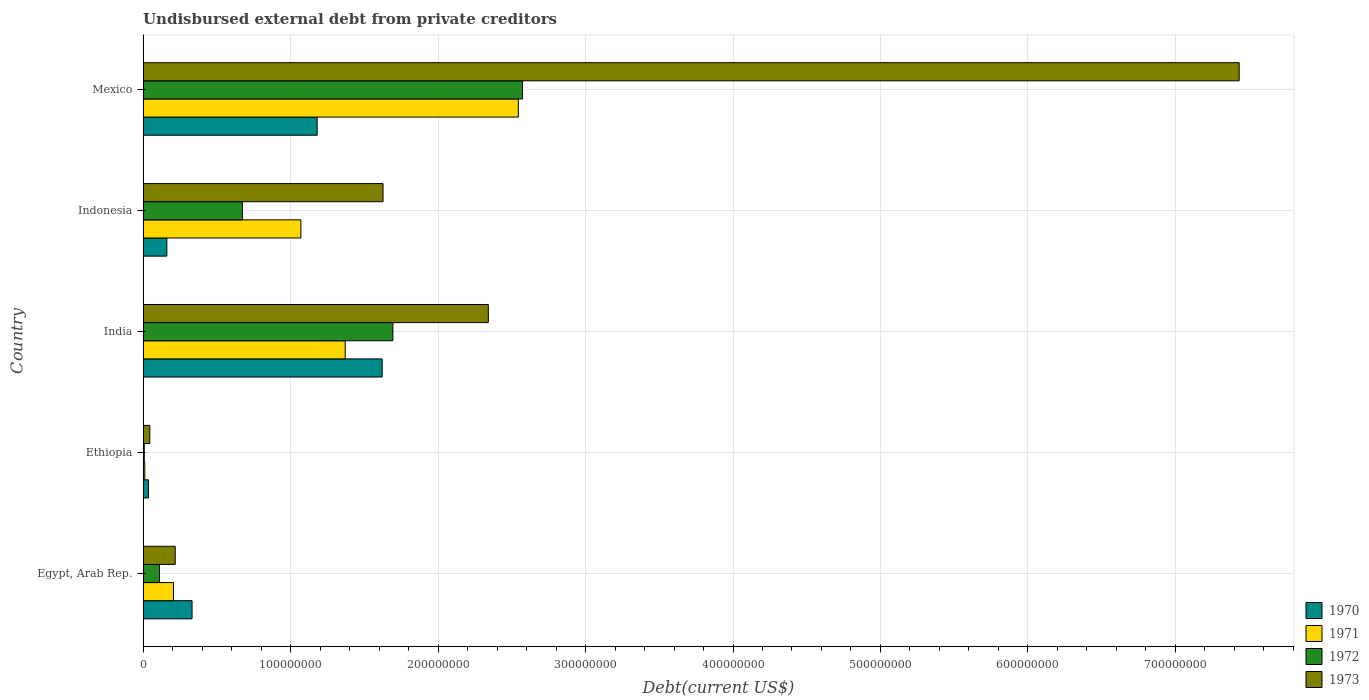How many different coloured bars are there?
Your answer should be compact. 4. How many groups of bars are there?
Your answer should be compact. 5. Are the number of bars on each tick of the Y-axis equal?
Keep it short and to the point. Yes. What is the label of the 4th group of bars from the top?
Provide a succinct answer. Ethiopia. In how many cases, is the number of bars for a given country not equal to the number of legend labels?
Offer a terse response. 0. What is the total debt in 1971 in Indonesia?
Ensure brevity in your answer.  1.07e+08. Across all countries, what is the maximum total debt in 1972?
Provide a short and direct response. 2.57e+08. Across all countries, what is the minimum total debt in 1973?
Your answer should be very brief. 4.57e+06. In which country was the total debt in 1971 maximum?
Your answer should be very brief. Mexico. In which country was the total debt in 1970 minimum?
Provide a short and direct response. Ethiopia. What is the total total debt in 1973 in the graph?
Provide a short and direct response. 1.17e+09. What is the difference between the total debt in 1973 in India and that in Mexico?
Your response must be concise. -5.09e+08. What is the difference between the total debt in 1972 in Mexico and the total debt in 1970 in Ethiopia?
Offer a very short reply. 2.54e+08. What is the average total debt in 1972 per country?
Provide a short and direct response. 1.01e+08. What is the difference between the total debt in 1970 and total debt in 1973 in India?
Keep it short and to the point. -7.20e+07. In how many countries, is the total debt in 1971 greater than 100000000 US$?
Ensure brevity in your answer.  3. What is the ratio of the total debt in 1971 in Ethiopia to that in Indonesia?
Provide a succinct answer. 0.01. What is the difference between the highest and the second highest total debt in 1972?
Your answer should be very brief. 8.79e+07. What is the difference between the highest and the lowest total debt in 1970?
Ensure brevity in your answer.  1.58e+08. In how many countries, is the total debt in 1972 greater than the average total debt in 1972 taken over all countries?
Your response must be concise. 2. Is the sum of the total debt in 1972 in Indonesia and Mexico greater than the maximum total debt in 1973 across all countries?
Provide a succinct answer. No. How many bars are there?
Your answer should be compact. 20. Are all the bars in the graph horizontal?
Your response must be concise. Yes. Are the values on the major ticks of X-axis written in scientific E-notation?
Your response must be concise. No. Where does the legend appear in the graph?
Ensure brevity in your answer.  Bottom right. How many legend labels are there?
Offer a terse response. 4. How are the legend labels stacked?
Your answer should be very brief. Vertical. What is the title of the graph?
Offer a very short reply. Undisbursed external debt from private creditors. Does "1990" appear as one of the legend labels in the graph?
Ensure brevity in your answer.  No. What is the label or title of the X-axis?
Make the answer very short. Debt(current US$). What is the label or title of the Y-axis?
Provide a short and direct response. Country. What is the Debt(current US$) in 1970 in Egypt, Arab Rep.?
Your answer should be very brief. 3.32e+07. What is the Debt(current US$) of 1971 in Egypt, Arab Rep.?
Give a very brief answer. 2.06e+07. What is the Debt(current US$) of 1972 in Egypt, Arab Rep.?
Your response must be concise. 1.11e+07. What is the Debt(current US$) of 1973 in Egypt, Arab Rep.?
Offer a terse response. 2.18e+07. What is the Debt(current US$) of 1970 in Ethiopia?
Your response must be concise. 3.70e+06. What is the Debt(current US$) of 1971 in Ethiopia?
Offer a very short reply. 1.16e+06. What is the Debt(current US$) in 1972 in Ethiopia?
Ensure brevity in your answer.  8.20e+05. What is the Debt(current US$) of 1973 in Ethiopia?
Provide a succinct answer. 4.57e+06. What is the Debt(current US$) in 1970 in India?
Keep it short and to the point. 1.62e+08. What is the Debt(current US$) of 1971 in India?
Provide a short and direct response. 1.37e+08. What is the Debt(current US$) in 1972 in India?
Offer a very short reply. 1.69e+08. What is the Debt(current US$) of 1973 in India?
Your response must be concise. 2.34e+08. What is the Debt(current US$) in 1970 in Indonesia?
Provide a short and direct response. 1.61e+07. What is the Debt(current US$) of 1971 in Indonesia?
Provide a succinct answer. 1.07e+08. What is the Debt(current US$) of 1972 in Indonesia?
Make the answer very short. 6.74e+07. What is the Debt(current US$) of 1973 in Indonesia?
Offer a very short reply. 1.63e+08. What is the Debt(current US$) of 1970 in Mexico?
Make the answer very short. 1.18e+08. What is the Debt(current US$) in 1971 in Mexico?
Offer a very short reply. 2.54e+08. What is the Debt(current US$) in 1972 in Mexico?
Give a very brief answer. 2.57e+08. What is the Debt(current US$) of 1973 in Mexico?
Provide a short and direct response. 7.43e+08. Across all countries, what is the maximum Debt(current US$) in 1970?
Your answer should be very brief. 1.62e+08. Across all countries, what is the maximum Debt(current US$) of 1971?
Your answer should be compact. 2.54e+08. Across all countries, what is the maximum Debt(current US$) of 1972?
Provide a succinct answer. 2.57e+08. Across all countries, what is the maximum Debt(current US$) in 1973?
Keep it short and to the point. 7.43e+08. Across all countries, what is the minimum Debt(current US$) in 1970?
Your answer should be compact. 3.70e+06. Across all countries, what is the minimum Debt(current US$) of 1971?
Make the answer very short. 1.16e+06. Across all countries, what is the minimum Debt(current US$) in 1972?
Give a very brief answer. 8.20e+05. Across all countries, what is the minimum Debt(current US$) in 1973?
Keep it short and to the point. 4.57e+06. What is the total Debt(current US$) in 1970 in the graph?
Your answer should be compact. 3.33e+08. What is the total Debt(current US$) in 1971 in the graph?
Give a very brief answer. 5.20e+08. What is the total Debt(current US$) of 1972 in the graph?
Your answer should be compact. 5.06e+08. What is the total Debt(current US$) of 1973 in the graph?
Give a very brief answer. 1.17e+09. What is the difference between the Debt(current US$) in 1970 in Egypt, Arab Rep. and that in Ethiopia?
Ensure brevity in your answer.  2.95e+07. What is the difference between the Debt(current US$) in 1971 in Egypt, Arab Rep. and that in Ethiopia?
Provide a succinct answer. 1.95e+07. What is the difference between the Debt(current US$) in 1972 in Egypt, Arab Rep. and that in Ethiopia?
Your answer should be compact. 1.03e+07. What is the difference between the Debt(current US$) in 1973 in Egypt, Arab Rep. and that in Ethiopia?
Offer a terse response. 1.72e+07. What is the difference between the Debt(current US$) in 1970 in Egypt, Arab Rep. and that in India?
Offer a terse response. -1.29e+08. What is the difference between the Debt(current US$) in 1971 in Egypt, Arab Rep. and that in India?
Provide a short and direct response. -1.16e+08. What is the difference between the Debt(current US$) of 1972 in Egypt, Arab Rep. and that in India?
Offer a terse response. -1.58e+08. What is the difference between the Debt(current US$) of 1973 in Egypt, Arab Rep. and that in India?
Offer a very short reply. -2.12e+08. What is the difference between the Debt(current US$) of 1970 in Egypt, Arab Rep. and that in Indonesia?
Your response must be concise. 1.71e+07. What is the difference between the Debt(current US$) of 1971 in Egypt, Arab Rep. and that in Indonesia?
Give a very brief answer. -8.64e+07. What is the difference between the Debt(current US$) in 1972 in Egypt, Arab Rep. and that in Indonesia?
Give a very brief answer. -5.62e+07. What is the difference between the Debt(current US$) of 1973 in Egypt, Arab Rep. and that in Indonesia?
Provide a succinct answer. -1.41e+08. What is the difference between the Debt(current US$) of 1970 in Egypt, Arab Rep. and that in Mexico?
Provide a short and direct response. -8.48e+07. What is the difference between the Debt(current US$) in 1971 in Egypt, Arab Rep. and that in Mexico?
Give a very brief answer. -2.34e+08. What is the difference between the Debt(current US$) of 1972 in Egypt, Arab Rep. and that in Mexico?
Your response must be concise. -2.46e+08. What is the difference between the Debt(current US$) in 1973 in Egypt, Arab Rep. and that in Mexico?
Make the answer very short. -7.21e+08. What is the difference between the Debt(current US$) of 1970 in Ethiopia and that in India?
Offer a terse response. -1.58e+08. What is the difference between the Debt(current US$) of 1971 in Ethiopia and that in India?
Your response must be concise. -1.36e+08. What is the difference between the Debt(current US$) in 1972 in Ethiopia and that in India?
Your answer should be compact. -1.69e+08. What is the difference between the Debt(current US$) in 1973 in Ethiopia and that in India?
Offer a very short reply. -2.30e+08. What is the difference between the Debt(current US$) of 1970 in Ethiopia and that in Indonesia?
Keep it short and to the point. -1.24e+07. What is the difference between the Debt(current US$) of 1971 in Ethiopia and that in Indonesia?
Provide a succinct answer. -1.06e+08. What is the difference between the Debt(current US$) in 1972 in Ethiopia and that in Indonesia?
Provide a succinct answer. -6.66e+07. What is the difference between the Debt(current US$) in 1973 in Ethiopia and that in Indonesia?
Ensure brevity in your answer.  -1.58e+08. What is the difference between the Debt(current US$) in 1970 in Ethiopia and that in Mexico?
Your response must be concise. -1.14e+08. What is the difference between the Debt(current US$) in 1971 in Ethiopia and that in Mexico?
Provide a short and direct response. -2.53e+08. What is the difference between the Debt(current US$) of 1972 in Ethiopia and that in Mexico?
Make the answer very short. -2.56e+08. What is the difference between the Debt(current US$) in 1973 in Ethiopia and that in Mexico?
Your response must be concise. -7.39e+08. What is the difference between the Debt(current US$) in 1970 in India and that in Indonesia?
Offer a very short reply. 1.46e+08. What is the difference between the Debt(current US$) of 1971 in India and that in Indonesia?
Your answer should be very brief. 3.00e+07. What is the difference between the Debt(current US$) in 1972 in India and that in Indonesia?
Give a very brief answer. 1.02e+08. What is the difference between the Debt(current US$) of 1973 in India and that in Indonesia?
Offer a terse response. 7.14e+07. What is the difference between the Debt(current US$) of 1970 in India and that in Mexico?
Offer a very short reply. 4.41e+07. What is the difference between the Debt(current US$) of 1971 in India and that in Mexico?
Provide a succinct answer. -1.17e+08. What is the difference between the Debt(current US$) in 1972 in India and that in Mexico?
Your response must be concise. -8.79e+07. What is the difference between the Debt(current US$) of 1973 in India and that in Mexico?
Keep it short and to the point. -5.09e+08. What is the difference between the Debt(current US$) in 1970 in Indonesia and that in Mexico?
Provide a succinct answer. -1.02e+08. What is the difference between the Debt(current US$) of 1971 in Indonesia and that in Mexico?
Give a very brief answer. -1.47e+08. What is the difference between the Debt(current US$) in 1972 in Indonesia and that in Mexico?
Your response must be concise. -1.90e+08. What is the difference between the Debt(current US$) in 1973 in Indonesia and that in Mexico?
Your response must be concise. -5.81e+08. What is the difference between the Debt(current US$) of 1970 in Egypt, Arab Rep. and the Debt(current US$) of 1971 in Ethiopia?
Offer a very short reply. 3.21e+07. What is the difference between the Debt(current US$) in 1970 in Egypt, Arab Rep. and the Debt(current US$) in 1972 in Ethiopia?
Give a very brief answer. 3.24e+07. What is the difference between the Debt(current US$) of 1970 in Egypt, Arab Rep. and the Debt(current US$) of 1973 in Ethiopia?
Provide a short and direct response. 2.87e+07. What is the difference between the Debt(current US$) in 1971 in Egypt, Arab Rep. and the Debt(current US$) in 1972 in Ethiopia?
Ensure brevity in your answer.  1.98e+07. What is the difference between the Debt(current US$) in 1971 in Egypt, Arab Rep. and the Debt(current US$) in 1973 in Ethiopia?
Keep it short and to the point. 1.61e+07. What is the difference between the Debt(current US$) in 1972 in Egypt, Arab Rep. and the Debt(current US$) in 1973 in Ethiopia?
Make the answer very short. 6.56e+06. What is the difference between the Debt(current US$) of 1970 in Egypt, Arab Rep. and the Debt(current US$) of 1971 in India?
Provide a short and direct response. -1.04e+08. What is the difference between the Debt(current US$) in 1970 in Egypt, Arab Rep. and the Debt(current US$) in 1972 in India?
Offer a very short reply. -1.36e+08. What is the difference between the Debt(current US$) in 1970 in Egypt, Arab Rep. and the Debt(current US$) in 1973 in India?
Make the answer very short. -2.01e+08. What is the difference between the Debt(current US$) of 1971 in Egypt, Arab Rep. and the Debt(current US$) of 1972 in India?
Ensure brevity in your answer.  -1.49e+08. What is the difference between the Debt(current US$) in 1971 in Egypt, Arab Rep. and the Debt(current US$) in 1973 in India?
Your answer should be compact. -2.13e+08. What is the difference between the Debt(current US$) of 1972 in Egypt, Arab Rep. and the Debt(current US$) of 1973 in India?
Your answer should be compact. -2.23e+08. What is the difference between the Debt(current US$) in 1970 in Egypt, Arab Rep. and the Debt(current US$) in 1971 in Indonesia?
Offer a terse response. -7.38e+07. What is the difference between the Debt(current US$) in 1970 in Egypt, Arab Rep. and the Debt(current US$) in 1972 in Indonesia?
Provide a succinct answer. -3.42e+07. What is the difference between the Debt(current US$) of 1970 in Egypt, Arab Rep. and the Debt(current US$) of 1973 in Indonesia?
Make the answer very short. -1.29e+08. What is the difference between the Debt(current US$) in 1971 in Egypt, Arab Rep. and the Debt(current US$) in 1972 in Indonesia?
Give a very brief answer. -4.67e+07. What is the difference between the Debt(current US$) of 1971 in Egypt, Arab Rep. and the Debt(current US$) of 1973 in Indonesia?
Provide a short and direct response. -1.42e+08. What is the difference between the Debt(current US$) in 1972 in Egypt, Arab Rep. and the Debt(current US$) in 1973 in Indonesia?
Keep it short and to the point. -1.52e+08. What is the difference between the Debt(current US$) of 1970 in Egypt, Arab Rep. and the Debt(current US$) of 1971 in Mexico?
Provide a short and direct response. -2.21e+08. What is the difference between the Debt(current US$) in 1970 in Egypt, Arab Rep. and the Debt(current US$) in 1972 in Mexico?
Keep it short and to the point. -2.24e+08. What is the difference between the Debt(current US$) in 1970 in Egypt, Arab Rep. and the Debt(current US$) in 1973 in Mexico?
Your answer should be very brief. -7.10e+08. What is the difference between the Debt(current US$) in 1971 in Egypt, Arab Rep. and the Debt(current US$) in 1972 in Mexico?
Your response must be concise. -2.37e+08. What is the difference between the Debt(current US$) in 1971 in Egypt, Arab Rep. and the Debt(current US$) in 1973 in Mexico?
Your answer should be compact. -7.23e+08. What is the difference between the Debt(current US$) of 1972 in Egypt, Arab Rep. and the Debt(current US$) of 1973 in Mexico?
Ensure brevity in your answer.  -7.32e+08. What is the difference between the Debt(current US$) in 1970 in Ethiopia and the Debt(current US$) in 1971 in India?
Your response must be concise. -1.33e+08. What is the difference between the Debt(current US$) in 1970 in Ethiopia and the Debt(current US$) in 1972 in India?
Provide a short and direct response. -1.66e+08. What is the difference between the Debt(current US$) of 1970 in Ethiopia and the Debt(current US$) of 1973 in India?
Provide a short and direct response. -2.30e+08. What is the difference between the Debt(current US$) in 1971 in Ethiopia and the Debt(current US$) in 1972 in India?
Ensure brevity in your answer.  -1.68e+08. What is the difference between the Debt(current US$) of 1971 in Ethiopia and the Debt(current US$) of 1973 in India?
Provide a short and direct response. -2.33e+08. What is the difference between the Debt(current US$) of 1972 in Ethiopia and the Debt(current US$) of 1973 in India?
Your answer should be very brief. -2.33e+08. What is the difference between the Debt(current US$) of 1970 in Ethiopia and the Debt(current US$) of 1971 in Indonesia?
Your answer should be compact. -1.03e+08. What is the difference between the Debt(current US$) in 1970 in Ethiopia and the Debt(current US$) in 1972 in Indonesia?
Provide a short and direct response. -6.37e+07. What is the difference between the Debt(current US$) of 1970 in Ethiopia and the Debt(current US$) of 1973 in Indonesia?
Your response must be concise. -1.59e+08. What is the difference between the Debt(current US$) in 1971 in Ethiopia and the Debt(current US$) in 1972 in Indonesia?
Make the answer very short. -6.62e+07. What is the difference between the Debt(current US$) in 1971 in Ethiopia and the Debt(current US$) in 1973 in Indonesia?
Make the answer very short. -1.62e+08. What is the difference between the Debt(current US$) in 1972 in Ethiopia and the Debt(current US$) in 1973 in Indonesia?
Your response must be concise. -1.62e+08. What is the difference between the Debt(current US$) in 1970 in Ethiopia and the Debt(current US$) in 1971 in Mexico?
Give a very brief answer. -2.51e+08. What is the difference between the Debt(current US$) of 1970 in Ethiopia and the Debt(current US$) of 1972 in Mexico?
Your response must be concise. -2.54e+08. What is the difference between the Debt(current US$) in 1970 in Ethiopia and the Debt(current US$) in 1973 in Mexico?
Your answer should be very brief. -7.40e+08. What is the difference between the Debt(current US$) in 1971 in Ethiopia and the Debt(current US$) in 1972 in Mexico?
Provide a succinct answer. -2.56e+08. What is the difference between the Debt(current US$) of 1971 in Ethiopia and the Debt(current US$) of 1973 in Mexico?
Your answer should be compact. -7.42e+08. What is the difference between the Debt(current US$) of 1972 in Ethiopia and the Debt(current US$) of 1973 in Mexico?
Make the answer very short. -7.42e+08. What is the difference between the Debt(current US$) of 1970 in India and the Debt(current US$) of 1971 in Indonesia?
Offer a terse response. 5.51e+07. What is the difference between the Debt(current US$) of 1970 in India and the Debt(current US$) of 1972 in Indonesia?
Offer a terse response. 9.47e+07. What is the difference between the Debt(current US$) of 1970 in India and the Debt(current US$) of 1973 in Indonesia?
Give a very brief answer. -5.84e+05. What is the difference between the Debt(current US$) of 1971 in India and the Debt(current US$) of 1972 in Indonesia?
Give a very brief answer. 6.97e+07. What is the difference between the Debt(current US$) in 1971 in India and the Debt(current US$) in 1973 in Indonesia?
Give a very brief answer. -2.56e+07. What is the difference between the Debt(current US$) in 1972 in India and the Debt(current US$) in 1973 in Indonesia?
Offer a very short reply. 6.68e+06. What is the difference between the Debt(current US$) in 1970 in India and the Debt(current US$) in 1971 in Mexico?
Your answer should be very brief. -9.23e+07. What is the difference between the Debt(current US$) of 1970 in India and the Debt(current US$) of 1972 in Mexico?
Your answer should be very brief. -9.51e+07. What is the difference between the Debt(current US$) of 1970 in India and the Debt(current US$) of 1973 in Mexico?
Your answer should be very brief. -5.81e+08. What is the difference between the Debt(current US$) in 1971 in India and the Debt(current US$) in 1972 in Mexico?
Keep it short and to the point. -1.20e+08. What is the difference between the Debt(current US$) of 1971 in India and the Debt(current US$) of 1973 in Mexico?
Provide a succinct answer. -6.06e+08. What is the difference between the Debt(current US$) of 1972 in India and the Debt(current US$) of 1973 in Mexico?
Make the answer very short. -5.74e+08. What is the difference between the Debt(current US$) of 1970 in Indonesia and the Debt(current US$) of 1971 in Mexico?
Ensure brevity in your answer.  -2.38e+08. What is the difference between the Debt(current US$) of 1970 in Indonesia and the Debt(current US$) of 1972 in Mexico?
Your answer should be compact. -2.41e+08. What is the difference between the Debt(current US$) in 1970 in Indonesia and the Debt(current US$) in 1973 in Mexico?
Your answer should be very brief. -7.27e+08. What is the difference between the Debt(current US$) of 1971 in Indonesia and the Debt(current US$) of 1972 in Mexico?
Your answer should be compact. -1.50e+08. What is the difference between the Debt(current US$) of 1971 in Indonesia and the Debt(current US$) of 1973 in Mexico?
Offer a terse response. -6.36e+08. What is the difference between the Debt(current US$) of 1972 in Indonesia and the Debt(current US$) of 1973 in Mexico?
Provide a succinct answer. -6.76e+08. What is the average Debt(current US$) in 1970 per country?
Your answer should be compact. 6.66e+07. What is the average Debt(current US$) of 1971 per country?
Your answer should be very brief. 1.04e+08. What is the average Debt(current US$) in 1972 per country?
Offer a very short reply. 1.01e+08. What is the average Debt(current US$) in 1973 per country?
Make the answer very short. 2.33e+08. What is the difference between the Debt(current US$) in 1970 and Debt(current US$) in 1971 in Egypt, Arab Rep.?
Ensure brevity in your answer.  1.26e+07. What is the difference between the Debt(current US$) in 1970 and Debt(current US$) in 1972 in Egypt, Arab Rep.?
Your answer should be compact. 2.21e+07. What is the difference between the Debt(current US$) in 1970 and Debt(current US$) in 1973 in Egypt, Arab Rep.?
Provide a short and direct response. 1.14e+07. What is the difference between the Debt(current US$) of 1971 and Debt(current US$) of 1972 in Egypt, Arab Rep.?
Provide a succinct answer. 9.50e+06. What is the difference between the Debt(current US$) in 1971 and Debt(current US$) in 1973 in Egypt, Arab Rep.?
Keep it short and to the point. -1.17e+06. What is the difference between the Debt(current US$) in 1972 and Debt(current US$) in 1973 in Egypt, Arab Rep.?
Your answer should be compact. -1.07e+07. What is the difference between the Debt(current US$) of 1970 and Debt(current US$) of 1971 in Ethiopia?
Your response must be concise. 2.53e+06. What is the difference between the Debt(current US$) in 1970 and Debt(current US$) in 1972 in Ethiopia?
Your response must be concise. 2.88e+06. What is the difference between the Debt(current US$) in 1970 and Debt(current US$) in 1973 in Ethiopia?
Provide a succinct answer. -8.70e+05. What is the difference between the Debt(current US$) in 1971 and Debt(current US$) in 1972 in Ethiopia?
Make the answer very short. 3.45e+05. What is the difference between the Debt(current US$) in 1971 and Debt(current US$) in 1973 in Ethiopia?
Provide a short and direct response. -3.40e+06. What is the difference between the Debt(current US$) in 1972 and Debt(current US$) in 1973 in Ethiopia?
Provide a short and direct response. -3.75e+06. What is the difference between the Debt(current US$) of 1970 and Debt(current US$) of 1971 in India?
Provide a succinct answer. 2.51e+07. What is the difference between the Debt(current US$) of 1970 and Debt(current US$) of 1972 in India?
Provide a short and direct response. -7.26e+06. What is the difference between the Debt(current US$) in 1970 and Debt(current US$) in 1973 in India?
Your answer should be compact. -7.20e+07. What is the difference between the Debt(current US$) in 1971 and Debt(current US$) in 1972 in India?
Your response must be concise. -3.23e+07. What is the difference between the Debt(current US$) of 1971 and Debt(current US$) of 1973 in India?
Your answer should be compact. -9.70e+07. What is the difference between the Debt(current US$) of 1972 and Debt(current US$) of 1973 in India?
Make the answer very short. -6.47e+07. What is the difference between the Debt(current US$) of 1970 and Debt(current US$) of 1971 in Indonesia?
Offer a terse response. -9.09e+07. What is the difference between the Debt(current US$) in 1970 and Debt(current US$) in 1972 in Indonesia?
Provide a succinct answer. -5.12e+07. What is the difference between the Debt(current US$) in 1970 and Debt(current US$) in 1973 in Indonesia?
Your answer should be very brief. -1.47e+08. What is the difference between the Debt(current US$) of 1971 and Debt(current US$) of 1972 in Indonesia?
Provide a succinct answer. 3.96e+07. What is the difference between the Debt(current US$) of 1971 and Debt(current US$) of 1973 in Indonesia?
Your answer should be compact. -5.57e+07. What is the difference between the Debt(current US$) in 1972 and Debt(current US$) in 1973 in Indonesia?
Keep it short and to the point. -9.53e+07. What is the difference between the Debt(current US$) of 1970 and Debt(current US$) of 1971 in Mexico?
Your answer should be very brief. -1.36e+08. What is the difference between the Debt(current US$) of 1970 and Debt(current US$) of 1972 in Mexico?
Keep it short and to the point. -1.39e+08. What is the difference between the Debt(current US$) in 1970 and Debt(current US$) in 1973 in Mexico?
Ensure brevity in your answer.  -6.25e+08. What is the difference between the Debt(current US$) in 1971 and Debt(current US$) in 1972 in Mexico?
Offer a terse response. -2.84e+06. What is the difference between the Debt(current US$) in 1971 and Debt(current US$) in 1973 in Mexico?
Give a very brief answer. -4.89e+08. What is the difference between the Debt(current US$) of 1972 and Debt(current US$) of 1973 in Mexico?
Your response must be concise. -4.86e+08. What is the ratio of the Debt(current US$) of 1970 in Egypt, Arab Rep. to that in Ethiopia?
Provide a short and direct response. 8.99. What is the ratio of the Debt(current US$) of 1971 in Egypt, Arab Rep. to that in Ethiopia?
Your answer should be very brief. 17.71. What is the ratio of the Debt(current US$) of 1972 in Egypt, Arab Rep. to that in Ethiopia?
Give a very brief answer. 13.57. What is the ratio of the Debt(current US$) in 1973 in Egypt, Arab Rep. to that in Ethiopia?
Keep it short and to the point. 4.77. What is the ratio of the Debt(current US$) of 1970 in Egypt, Arab Rep. to that in India?
Make the answer very short. 0.2. What is the ratio of the Debt(current US$) of 1971 in Egypt, Arab Rep. to that in India?
Provide a succinct answer. 0.15. What is the ratio of the Debt(current US$) of 1972 in Egypt, Arab Rep. to that in India?
Give a very brief answer. 0.07. What is the ratio of the Debt(current US$) of 1973 in Egypt, Arab Rep. to that in India?
Give a very brief answer. 0.09. What is the ratio of the Debt(current US$) of 1970 in Egypt, Arab Rep. to that in Indonesia?
Give a very brief answer. 2.06. What is the ratio of the Debt(current US$) of 1971 in Egypt, Arab Rep. to that in Indonesia?
Your answer should be very brief. 0.19. What is the ratio of the Debt(current US$) of 1972 in Egypt, Arab Rep. to that in Indonesia?
Your answer should be very brief. 0.17. What is the ratio of the Debt(current US$) in 1973 in Egypt, Arab Rep. to that in Indonesia?
Give a very brief answer. 0.13. What is the ratio of the Debt(current US$) in 1970 in Egypt, Arab Rep. to that in Mexico?
Give a very brief answer. 0.28. What is the ratio of the Debt(current US$) of 1971 in Egypt, Arab Rep. to that in Mexico?
Ensure brevity in your answer.  0.08. What is the ratio of the Debt(current US$) in 1972 in Egypt, Arab Rep. to that in Mexico?
Your answer should be compact. 0.04. What is the ratio of the Debt(current US$) in 1973 in Egypt, Arab Rep. to that in Mexico?
Give a very brief answer. 0.03. What is the ratio of the Debt(current US$) of 1970 in Ethiopia to that in India?
Offer a terse response. 0.02. What is the ratio of the Debt(current US$) in 1971 in Ethiopia to that in India?
Keep it short and to the point. 0.01. What is the ratio of the Debt(current US$) of 1972 in Ethiopia to that in India?
Your response must be concise. 0. What is the ratio of the Debt(current US$) in 1973 in Ethiopia to that in India?
Provide a succinct answer. 0.02. What is the ratio of the Debt(current US$) in 1970 in Ethiopia to that in Indonesia?
Your response must be concise. 0.23. What is the ratio of the Debt(current US$) of 1971 in Ethiopia to that in Indonesia?
Offer a terse response. 0.01. What is the ratio of the Debt(current US$) of 1972 in Ethiopia to that in Indonesia?
Your answer should be very brief. 0.01. What is the ratio of the Debt(current US$) of 1973 in Ethiopia to that in Indonesia?
Keep it short and to the point. 0.03. What is the ratio of the Debt(current US$) of 1970 in Ethiopia to that in Mexico?
Your answer should be very brief. 0.03. What is the ratio of the Debt(current US$) in 1971 in Ethiopia to that in Mexico?
Your answer should be very brief. 0. What is the ratio of the Debt(current US$) of 1972 in Ethiopia to that in Mexico?
Your answer should be very brief. 0. What is the ratio of the Debt(current US$) in 1973 in Ethiopia to that in Mexico?
Provide a succinct answer. 0.01. What is the ratio of the Debt(current US$) of 1970 in India to that in Indonesia?
Your response must be concise. 10.05. What is the ratio of the Debt(current US$) in 1971 in India to that in Indonesia?
Give a very brief answer. 1.28. What is the ratio of the Debt(current US$) of 1972 in India to that in Indonesia?
Your answer should be very brief. 2.51. What is the ratio of the Debt(current US$) in 1973 in India to that in Indonesia?
Offer a terse response. 1.44. What is the ratio of the Debt(current US$) of 1970 in India to that in Mexico?
Your answer should be very brief. 1.37. What is the ratio of the Debt(current US$) of 1971 in India to that in Mexico?
Give a very brief answer. 0.54. What is the ratio of the Debt(current US$) in 1972 in India to that in Mexico?
Keep it short and to the point. 0.66. What is the ratio of the Debt(current US$) of 1973 in India to that in Mexico?
Your answer should be very brief. 0.32. What is the ratio of the Debt(current US$) in 1970 in Indonesia to that in Mexico?
Offer a very short reply. 0.14. What is the ratio of the Debt(current US$) of 1971 in Indonesia to that in Mexico?
Keep it short and to the point. 0.42. What is the ratio of the Debt(current US$) in 1972 in Indonesia to that in Mexico?
Offer a terse response. 0.26. What is the ratio of the Debt(current US$) in 1973 in Indonesia to that in Mexico?
Your answer should be compact. 0.22. What is the difference between the highest and the second highest Debt(current US$) in 1970?
Your answer should be compact. 4.41e+07. What is the difference between the highest and the second highest Debt(current US$) of 1971?
Your answer should be compact. 1.17e+08. What is the difference between the highest and the second highest Debt(current US$) of 1972?
Provide a short and direct response. 8.79e+07. What is the difference between the highest and the second highest Debt(current US$) in 1973?
Your response must be concise. 5.09e+08. What is the difference between the highest and the lowest Debt(current US$) of 1970?
Your answer should be very brief. 1.58e+08. What is the difference between the highest and the lowest Debt(current US$) of 1971?
Keep it short and to the point. 2.53e+08. What is the difference between the highest and the lowest Debt(current US$) of 1972?
Provide a succinct answer. 2.56e+08. What is the difference between the highest and the lowest Debt(current US$) of 1973?
Make the answer very short. 7.39e+08. 